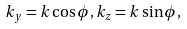<formula> <loc_0><loc_0><loc_500><loc_500>k _ { y } = k \cos \phi , k _ { z } = k \sin \phi ,</formula> 